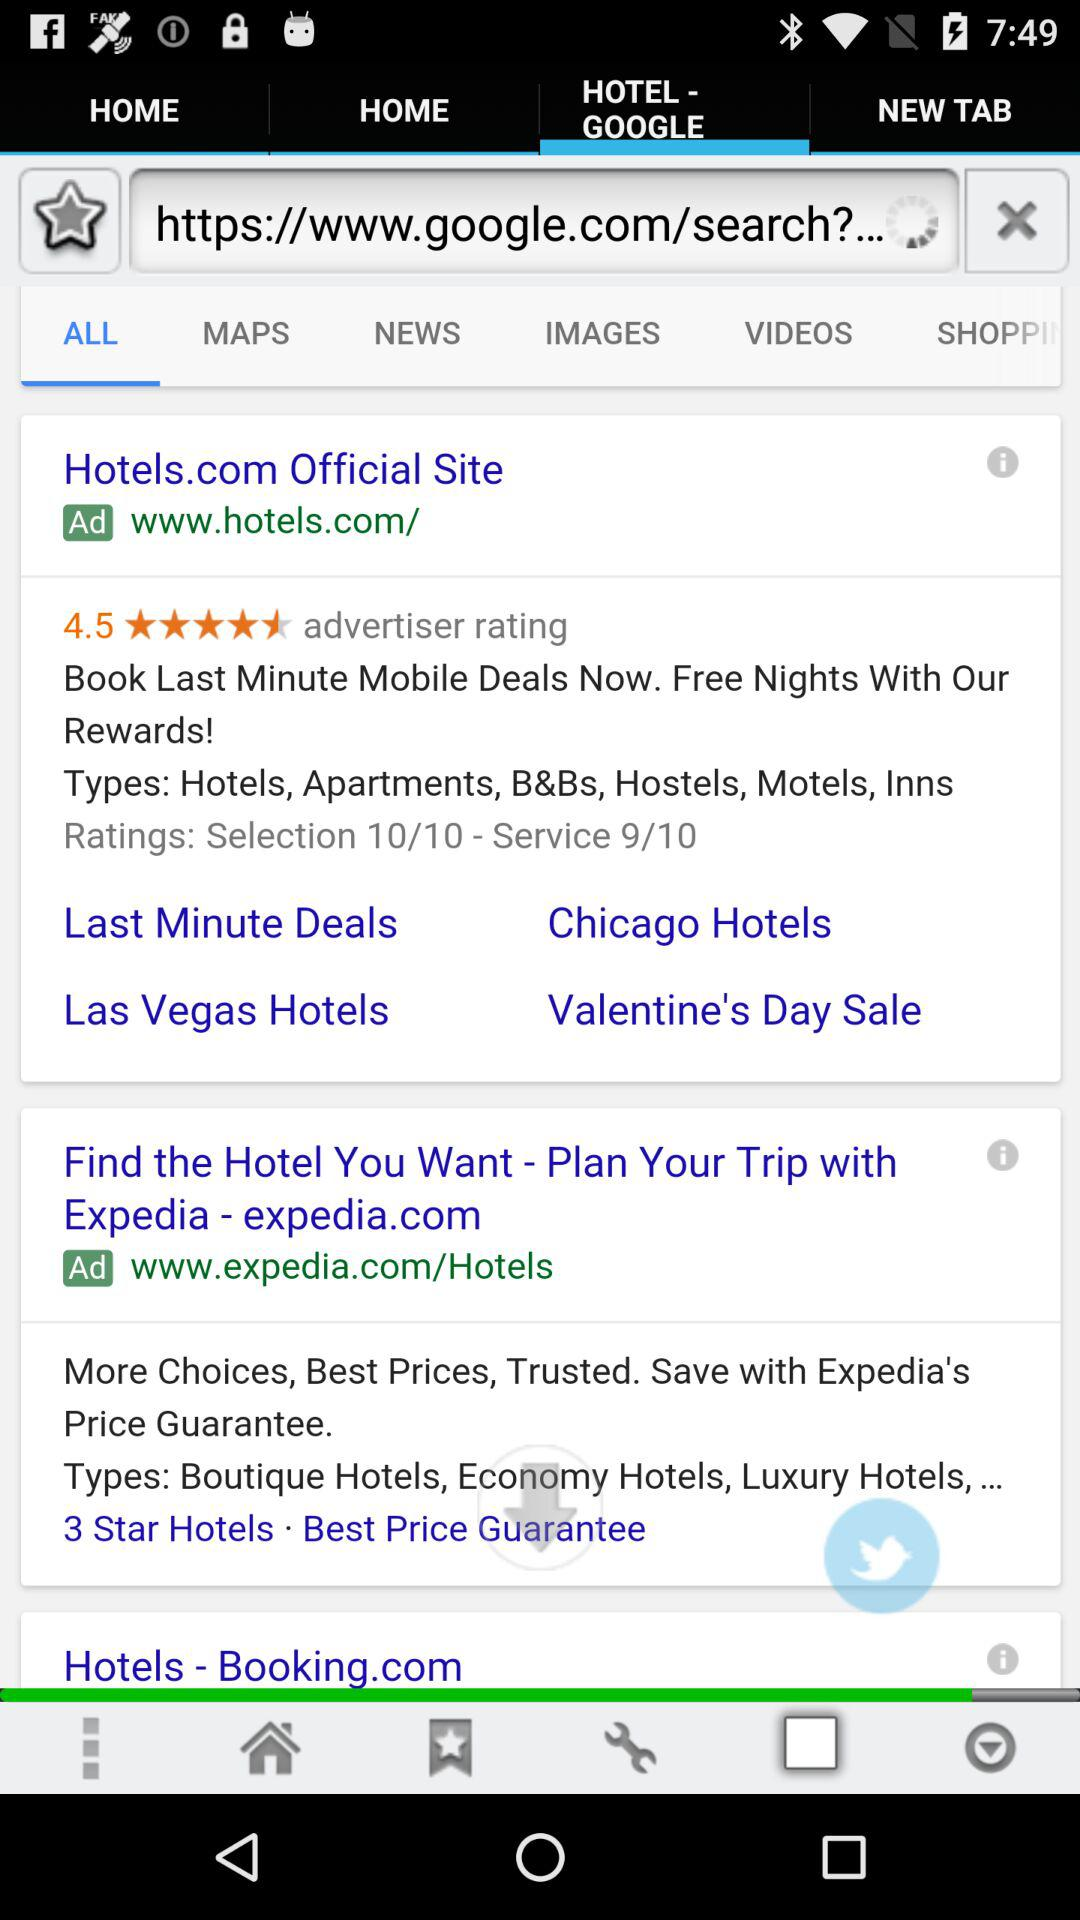What is the hotel website? The hotel websites are www.hotels.com/ and www.expedia.com/Hotels. 